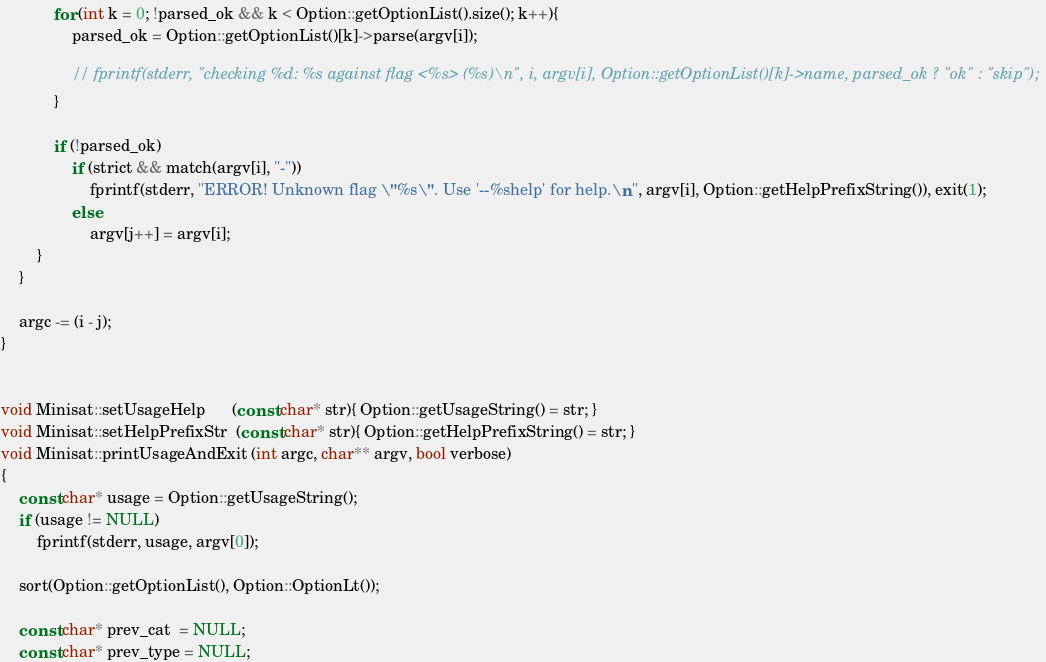<code> <loc_0><loc_0><loc_500><loc_500><_C++_>            for (int k = 0; !parsed_ok && k < Option::getOptionList().size(); k++){
                parsed_ok = Option::getOptionList()[k]->parse(argv[i]);

                // fprintf(stderr, "checking %d: %s against flag <%s> (%s)\n", i, argv[i], Option::getOptionList()[k]->name, parsed_ok ? "ok" : "skip");
            }

            if (!parsed_ok)
                if (strict && match(argv[i], "-"))
                    fprintf(stderr, "ERROR! Unknown flag \"%s\". Use '--%shelp' for help.\n", argv[i], Option::getHelpPrefixString()), exit(1);
                else
                    argv[j++] = argv[i];
        }
    }

    argc -= (i - j);
}


void Minisat::setUsageHelp      (const char* str){ Option::getUsageString() = str; }
void Minisat::setHelpPrefixStr  (const char* str){ Option::getHelpPrefixString() = str; }
void Minisat::printUsageAndExit (int argc, char** argv, bool verbose)
{
    const char* usage = Option::getUsageString();
    if (usage != NULL)
        fprintf(stderr, usage, argv[0]);

    sort(Option::getOptionList(), Option::OptionLt());

    const char* prev_cat  = NULL;
    const char* prev_type = NULL;
</code> 